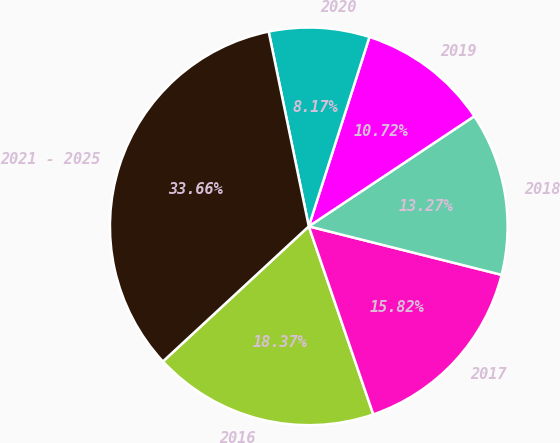Convert chart. <chart><loc_0><loc_0><loc_500><loc_500><pie_chart><fcel>2016<fcel>2017<fcel>2018<fcel>2019<fcel>2020<fcel>2021 - 2025<nl><fcel>18.37%<fcel>15.82%<fcel>13.27%<fcel>10.72%<fcel>8.17%<fcel>33.66%<nl></chart> 